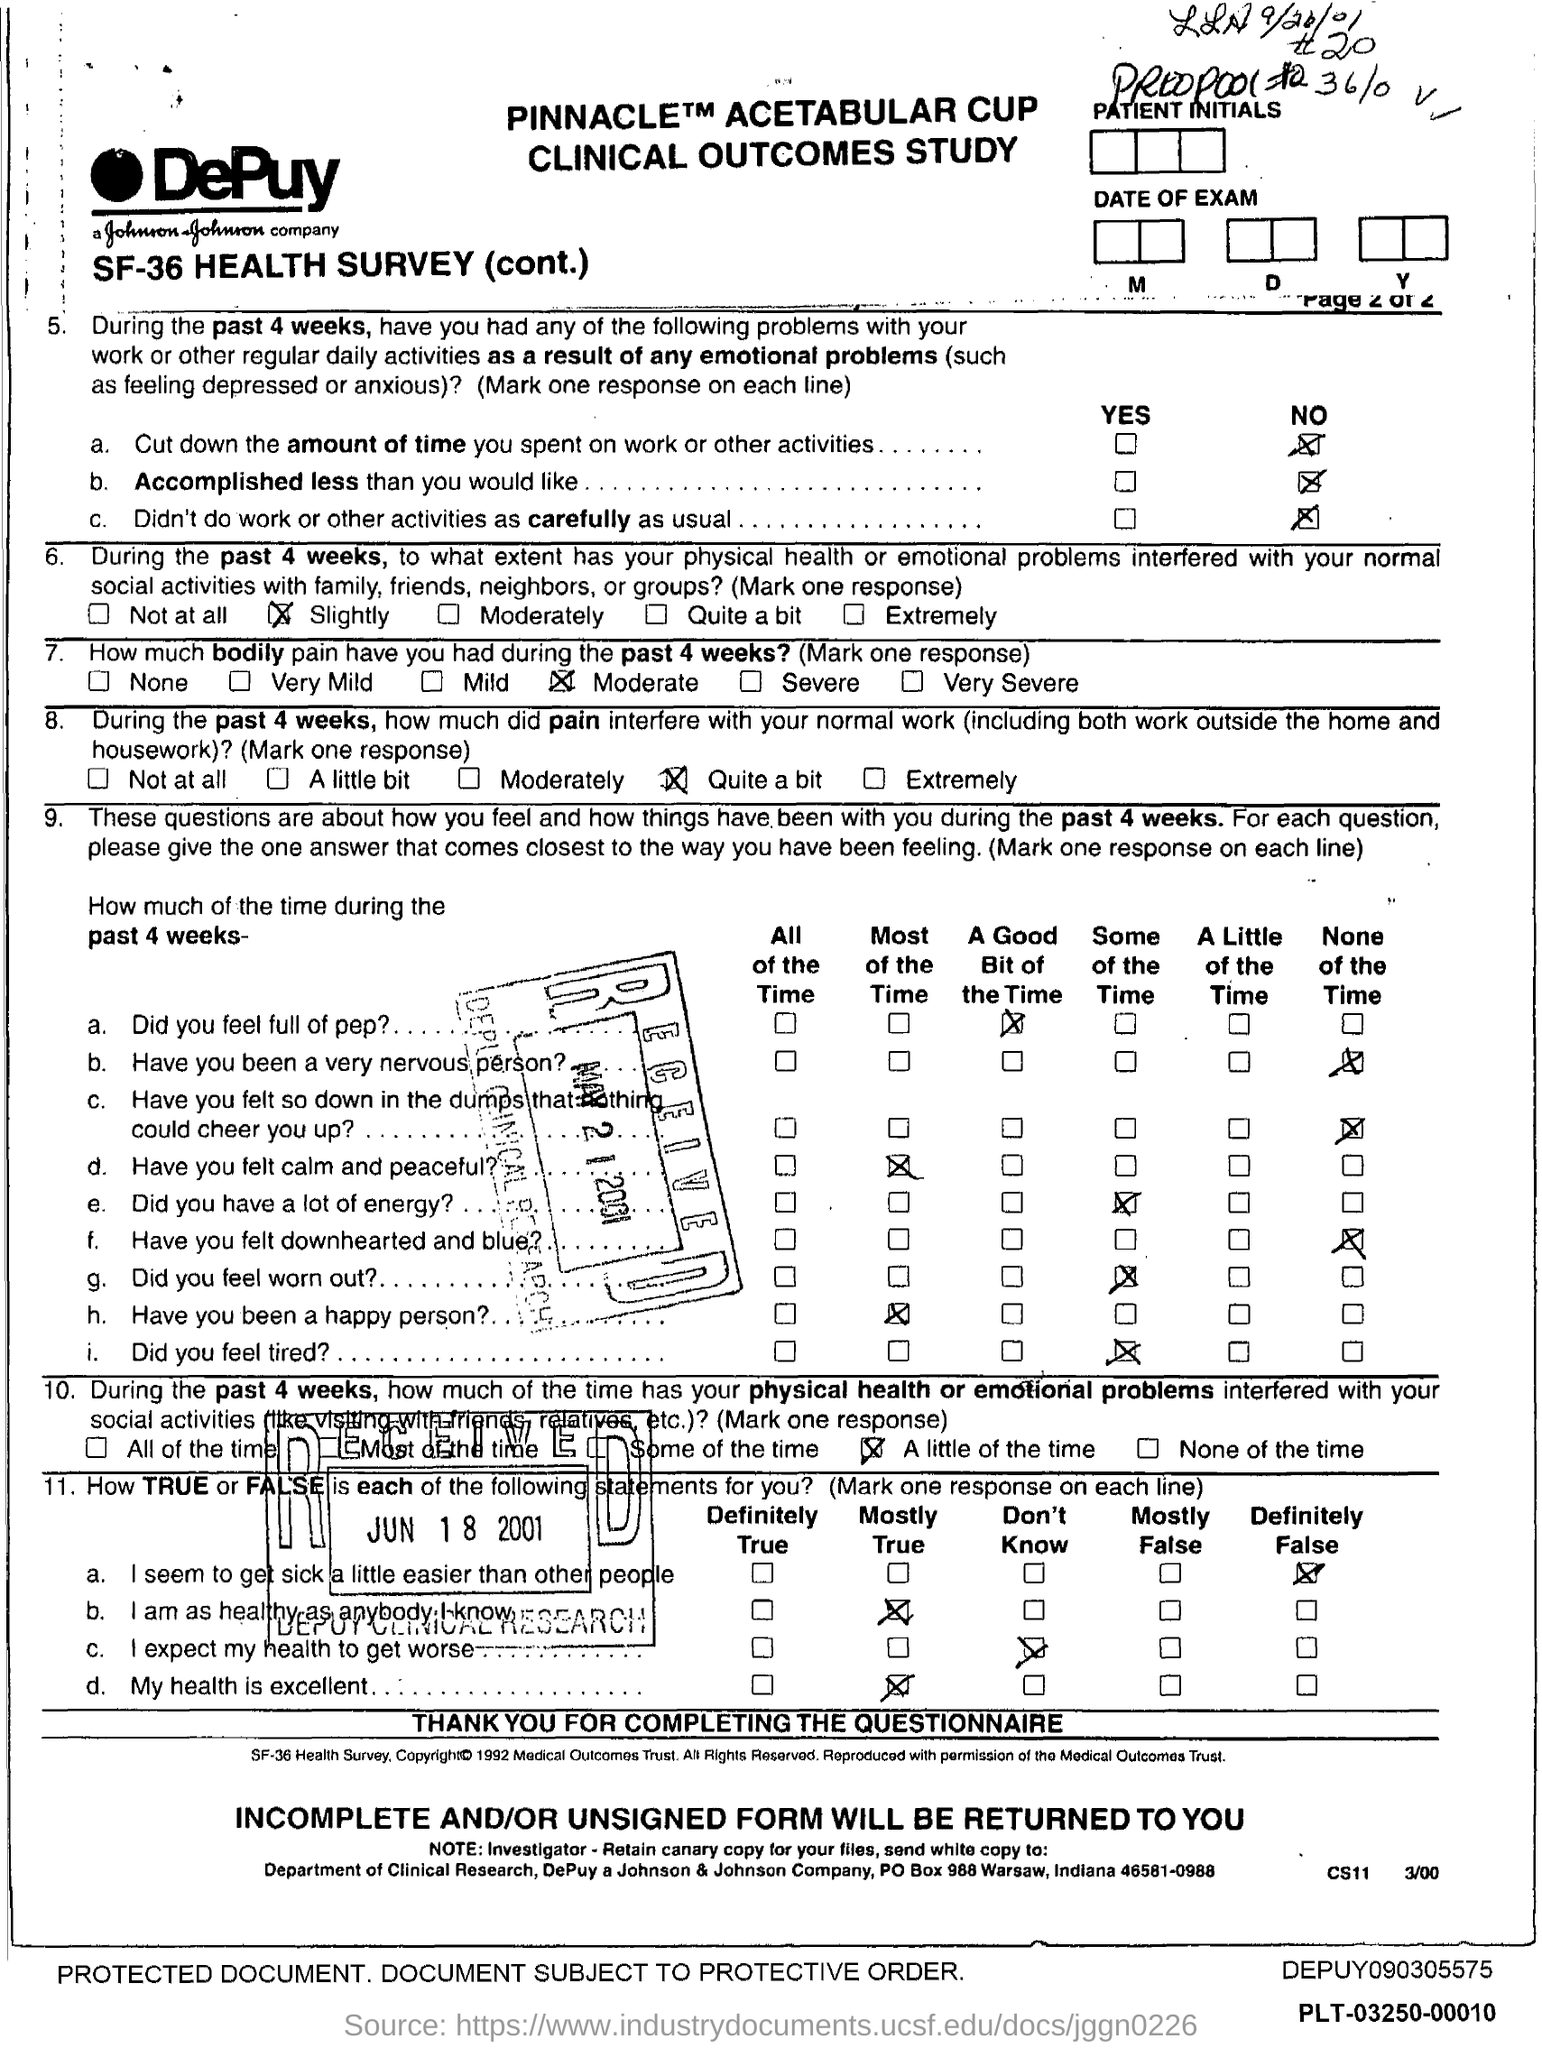List a handful of essential elements in this visual. The patient reported experiencing moderate bodily pain during the past four weeks. The date mentioned in the bottom most stamp is June 18, 2001. The patient did not accomplish less than he or she desired. The name of the company is DePuy. The patient did not seem to get sick easily compared to others. 